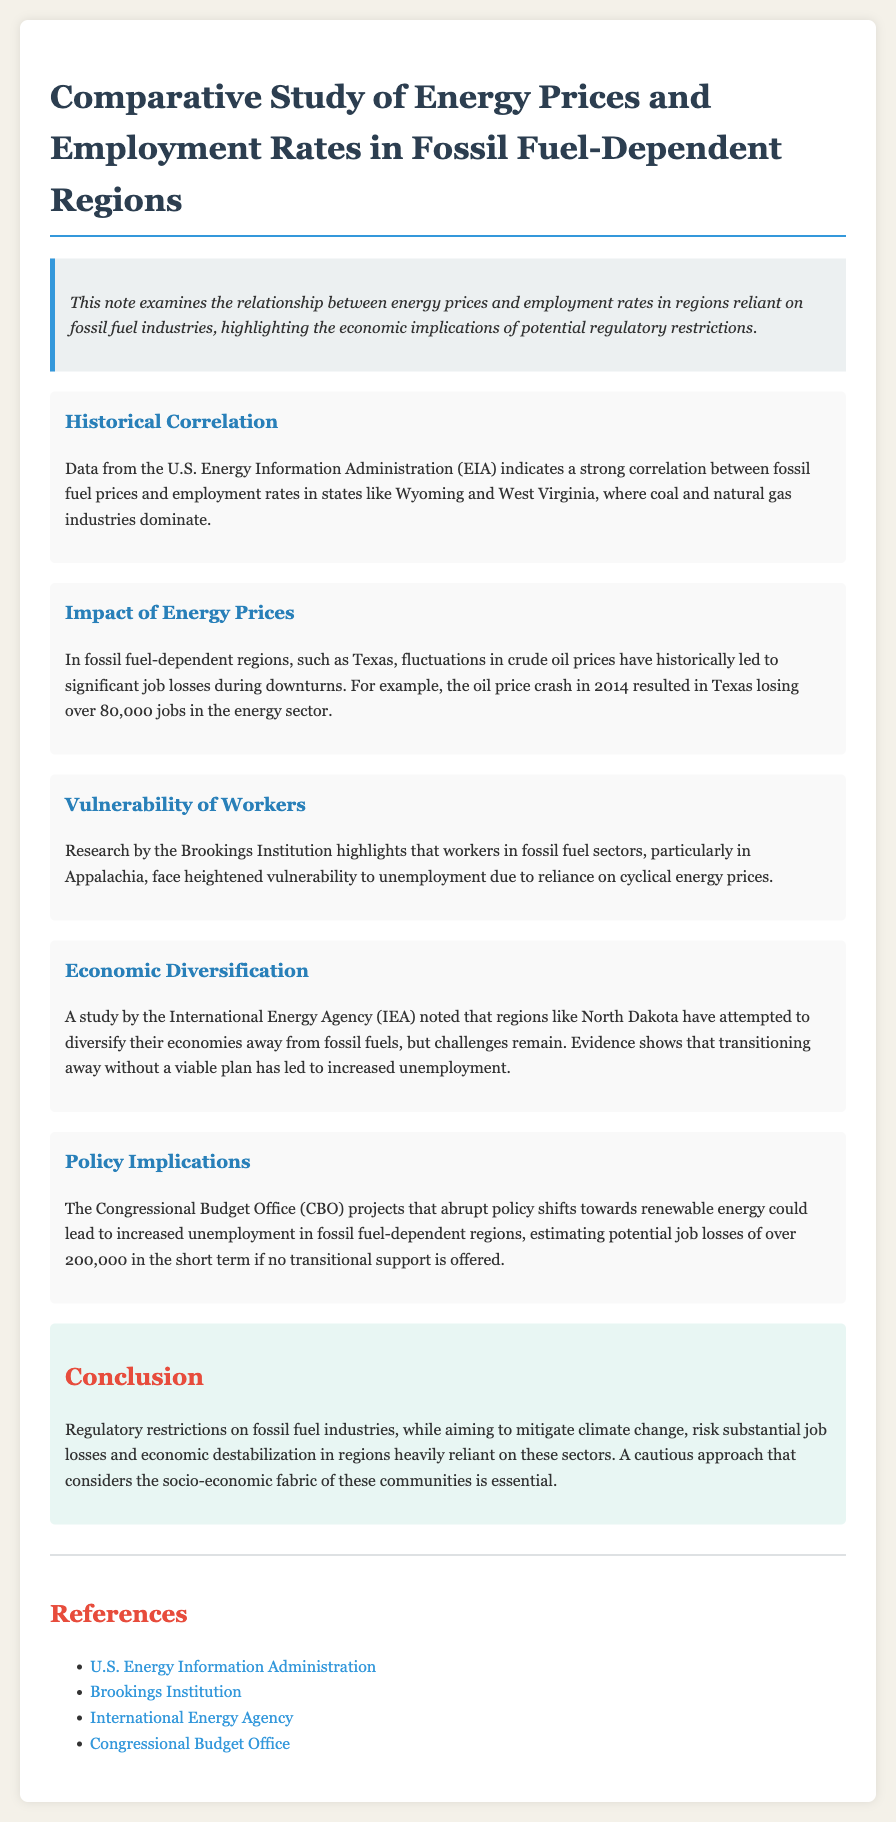What is the title of the document? The title of the document is stated clearly at the beginning, which is "Comparative Study of Energy Prices and Employment Rates in Fossil Fuel-Dependent Regions."
Answer: Comparative Study of Energy Prices and Employment Rates in Fossil Fuel-Dependent Regions Which organization provided data on historical correlation? The historical correlation data is mentioned as being provided by the U.S. Energy Information Administration (EIA).
Answer: U.S. Energy Information Administration What job loss number is mentioned for Texas after the 2014 oil price crash? The document specifies that Texas lost over 80,000 jobs in the energy sector due to the oil price crash in 2014.
Answer: Over 80,000 jobs According to the Brookings Institution, which area's workers are highlighted for heightened vulnerability? The document mentions that the workers in Appalachia are highlighted for their heightened vulnerability to unemployment.
Answer: Appalachia What potential job loss does the Congressional Budget Office estimate with abrupt policy shifts? The Congressional Budget Office estimates that abrupt policy shifts could lead to potential job losses of over 200,000.
Answer: Over 200,000 What is the document's conclusion focusing on regulatory restrictions? The conclusion emphasizes that regulatory restrictions on fossil fuel industries risk substantial job losses and economic destabilization.
Answer: Substantial job losses and economic destabilization 